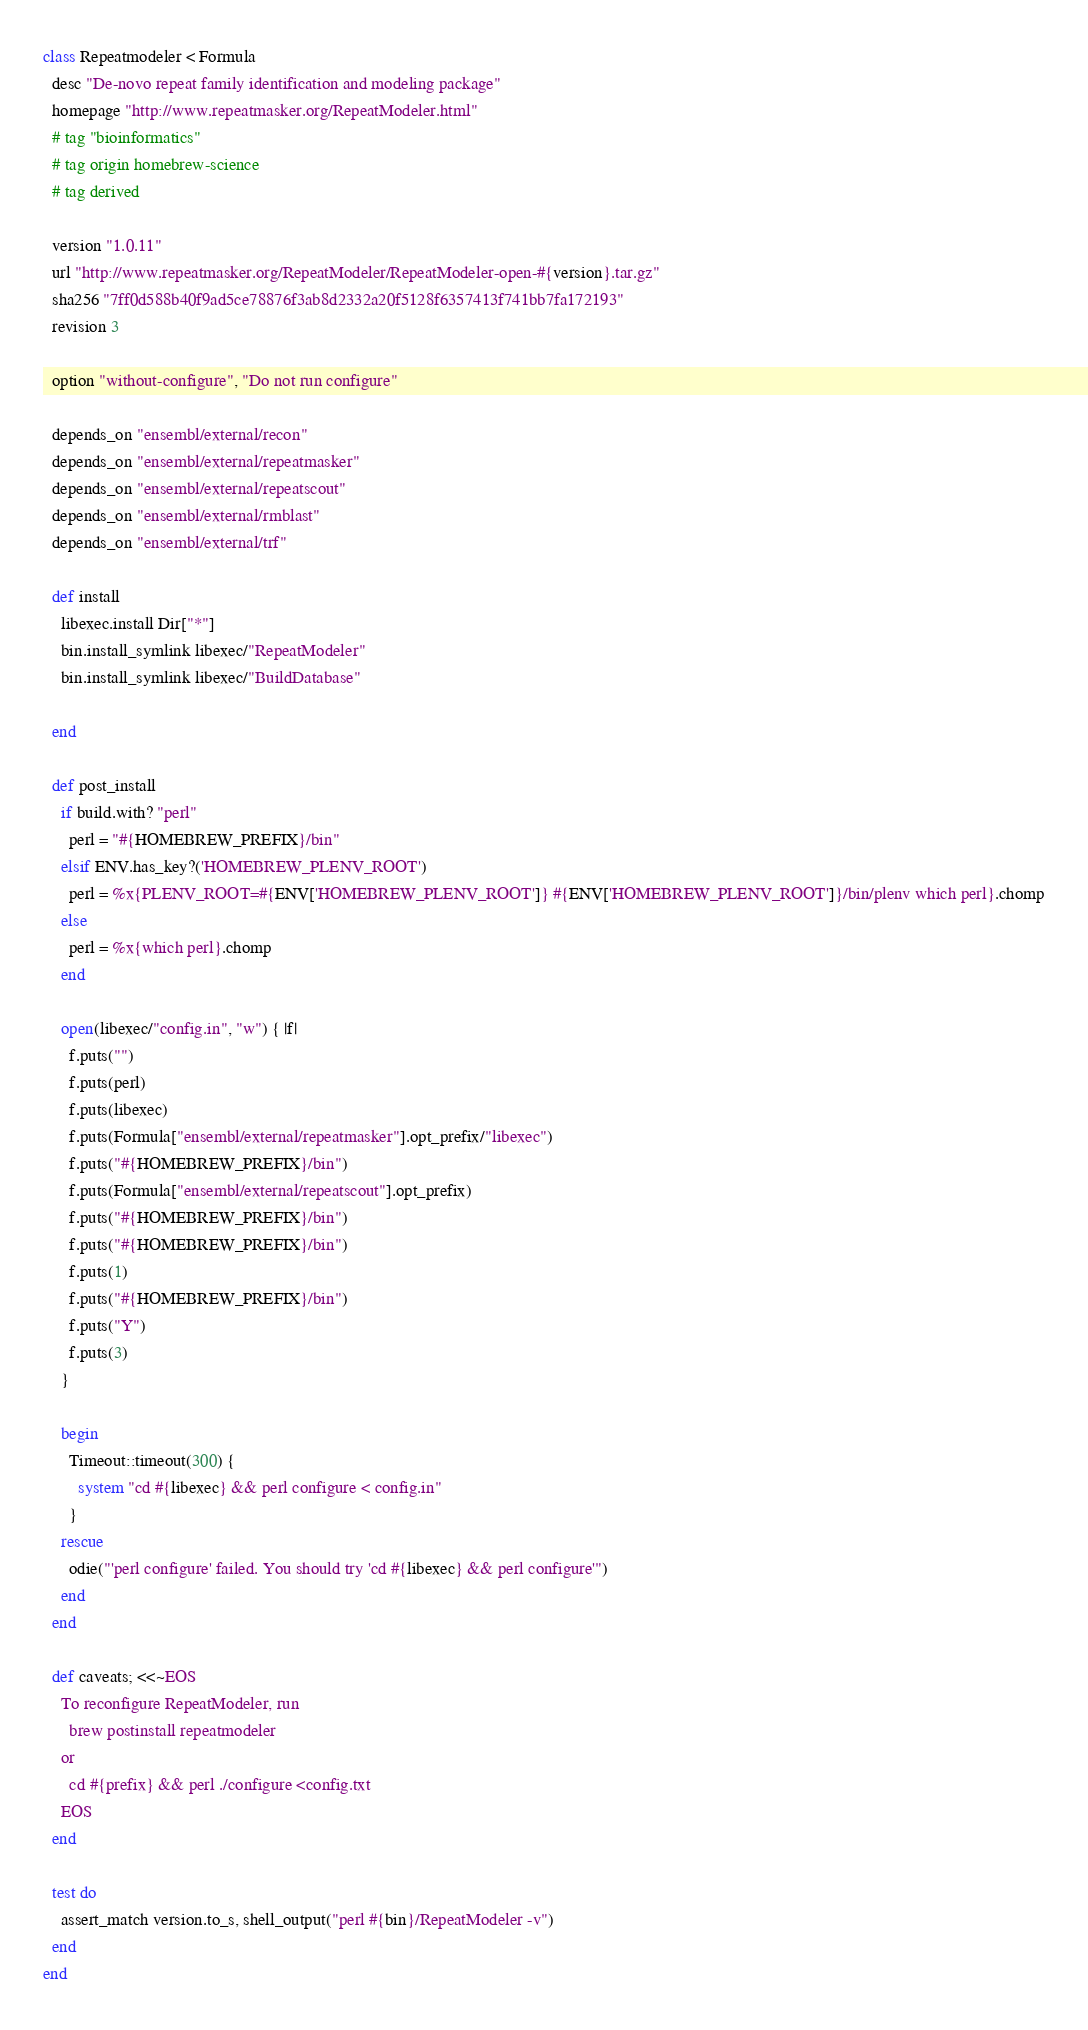<code> <loc_0><loc_0><loc_500><loc_500><_Ruby_>class Repeatmodeler < Formula
  desc "De-novo repeat family identification and modeling package"
  homepage "http://www.repeatmasker.org/RepeatModeler.html"
  # tag "bioinformatics"
  # tag origin homebrew-science
  # tag derived

  version "1.0.11"
  url "http://www.repeatmasker.org/RepeatModeler/RepeatModeler-open-#{version}.tar.gz"
  sha256 "7ff0d588b40f9ad5ce78876f3ab8d2332a20f5128f6357413f741bb7fa172193"
  revision 3

  option "without-configure", "Do not run configure"

  depends_on "ensembl/external/recon"
  depends_on "ensembl/external/repeatmasker"
  depends_on "ensembl/external/repeatscout"
  depends_on "ensembl/external/rmblast"
  depends_on "ensembl/external/trf"

  def install
    libexec.install Dir["*"]
    bin.install_symlink libexec/"RepeatModeler"
    bin.install_symlink libexec/"BuildDatabase"

  end

  def post_install
    if build.with? "perl"
      perl = "#{HOMEBREW_PREFIX}/bin"
    elsif ENV.has_key?('HOMEBREW_PLENV_ROOT')
      perl = %x{PLENV_ROOT=#{ENV['HOMEBREW_PLENV_ROOT']} #{ENV['HOMEBREW_PLENV_ROOT']}/bin/plenv which perl}.chomp
    else
      perl = %x{which perl}.chomp
    end

    open(libexec/"config.in", "w") { |f|
      f.puts("")
      f.puts(perl)
      f.puts(libexec)
      f.puts(Formula["ensembl/external/repeatmasker"].opt_prefix/"libexec")
      f.puts("#{HOMEBREW_PREFIX}/bin")
      f.puts(Formula["ensembl/external/repeatscout"].opt_prefix)
      f.puts("#{HOMEBREW_PREFIX}/bin")
      f.puts("#{HOMEBREW_PREFIX}/bin")
      f.puts(1)
      f.puts("#{HOMEBREW_PREFIX}/bin")
      f.puts("Y")
      f.puts(3)
    }

    begin
      Timeout::timeout(300) {
        system "cd #{libexec} && perl configure < config.in"
      }
    rescue
      odie("'perl configure' failed. You should try 'cd #{libexec} && perl configure'")
    end
  end

  def caveats; <<~EOS
    To reconfigure RepeatModeler, run
      brew postinstall repeatmodeler
    or
      cd #{prefix} && perl ./configure <config.txt
    EOS
  end

  test do
    assert_match version.to_s, shell_output("perl #{bin}/RepeatModeler -v")
  end
end
</code> 